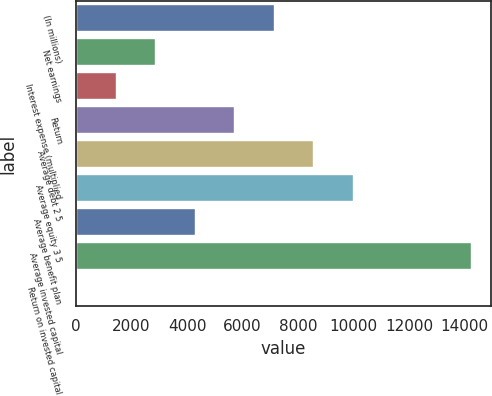Convert chart to OTSL. <chart><loc_0><loc_0><loc_500><loc_500><bar_chart><fcel>(In millions)<fcel>Net earnings<fcel>Interest expense (multiplied<fcel>Return<fcel>Average debt 2 5<fcel>Average equity 3 5<fcel>Average benefit plan<fcel>Average invested capital<fcel>Return on invested capital<nl><fcel>7126.9<fcel>2857.24<fcel>1434.02<fcel>5703.68<fcel>8550.12<fcel>9973.34<fcel>4280.46<fcel>14243<fcel>10.8<nl></chart> 